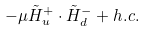<formula> <loc_0><loc_0><loc_500><loc_500>- \mu \tilde { H } ^ { + } _ { u } \cdot \tilde { H } ^ { - } _ { d } + h . c .</formula> 